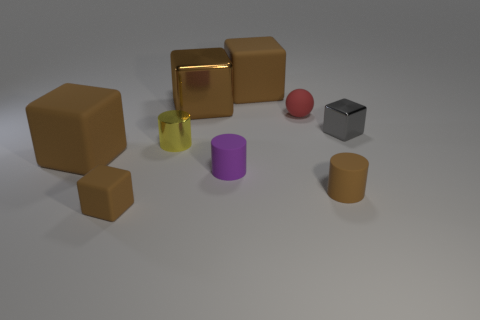Subtract all brown cubes. How many were subtracted if there are1brown cubes left? 3 Subtract all gray blocks. How many blocks are left? 4 Subtract all purple cylinders. How many cylinders are left? 2 Subtract all spheres. How many objects are left? 8 Subtract all gray cylinders. How many brown cubes are left? 4 Subtract all big brown objects. Subtract all rubber cylinders. How many objects are left? 4 Add 3 gray metallic blocks. How many gray metallic blocks are left? 4 Add 7 tiny purple objects. How many tiny purple objects exist? 8 Subtract 0 purple blocks. How many objects are left? 9 Subtract 2 cubes. How many cubes are left? 3 